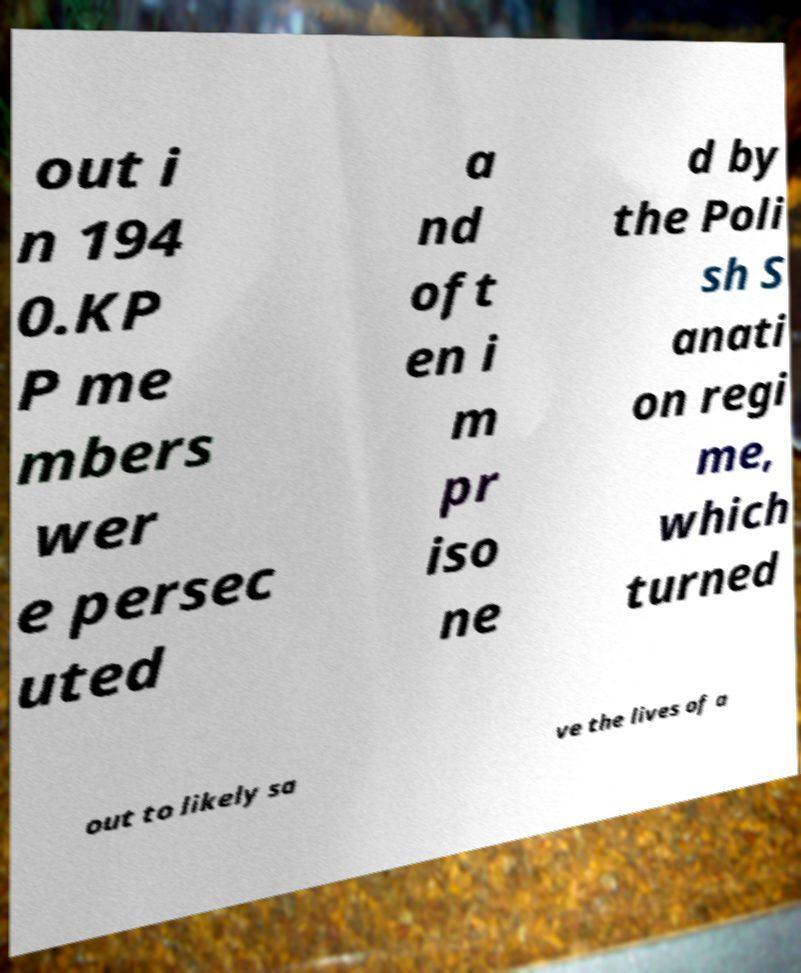Please identify and transcribe the text found in this image. out i n 194 0.KP P me mbers wer e persec uted a nd oft en i m pr iso ne d by the Poli sh S anati on regi me, which turned out to likely sa ve the lives of a 